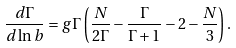Convert formula to latex. <formula><loc_0><loc_0><loc_500><loc_500>\frac { d \Gamma } { d \ln b } = g \Gamma \left ( \frac { N } { 2 \Gamma } - \frac { \Gamma } { \Gamma + 1 } - 2 - \frac { N } { 3 } \right ) .</formula> 